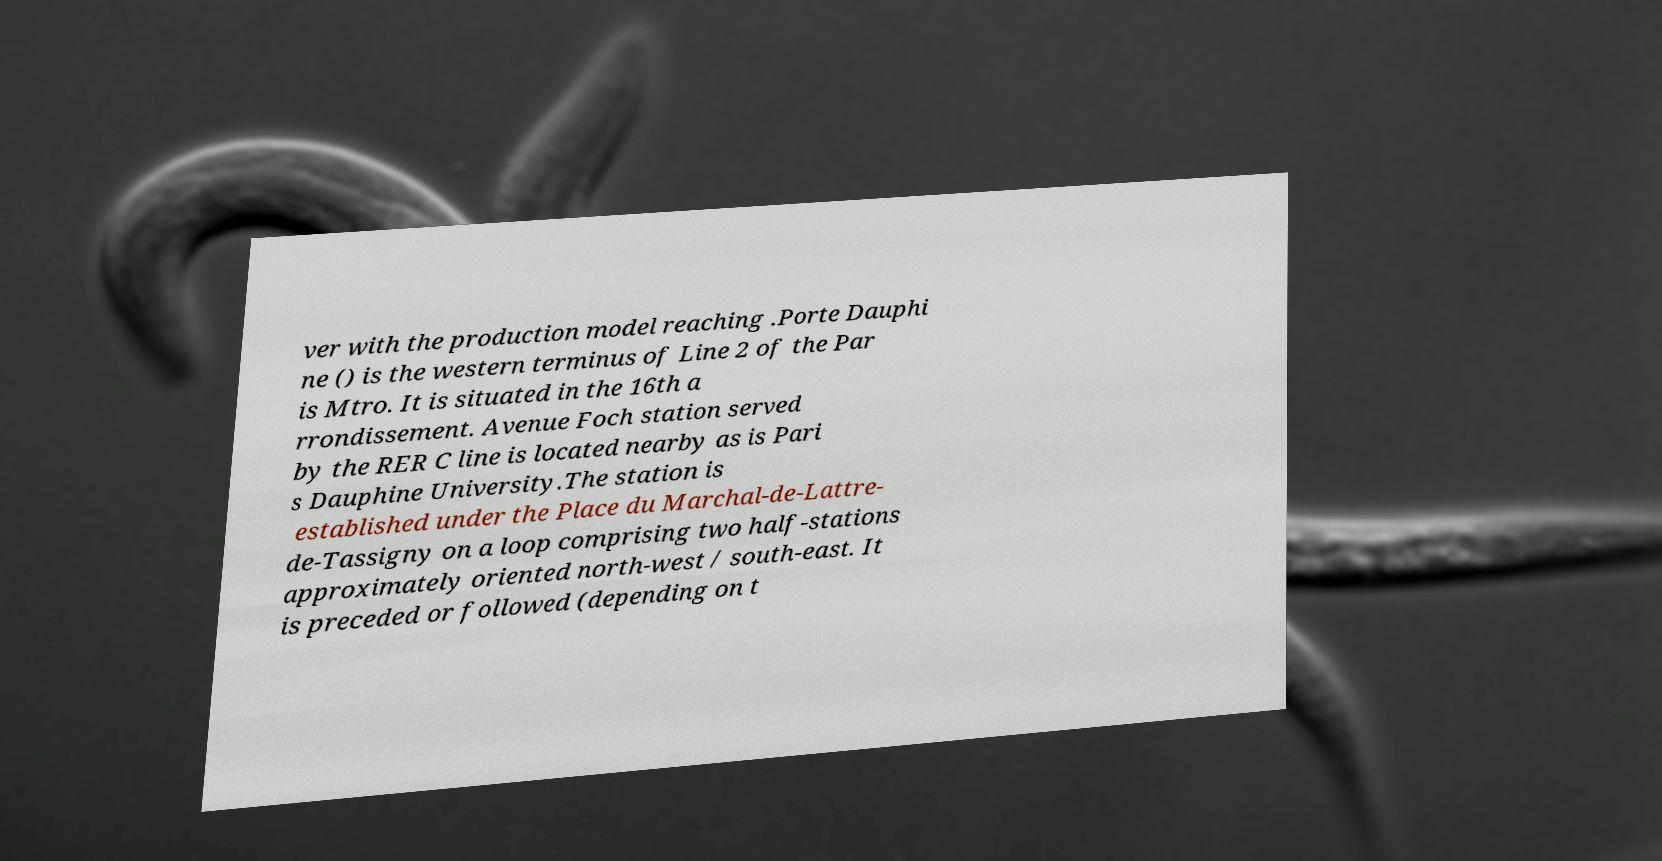What messages or text are displayed in this image? I need them in a readable, typed format. ver with the production model reaching .Porte Dauphi ne () is the western terminus of Line 2 of the Par is Mtro. It is situated in the 16th a rrondissement. Avenue Foch station served by the RER C line is located nearby as is Pari s Dauphine University.The station is established under the Place du Marchal-de-Lattre- de-Tassigny on a loop comprising two half-stations approximately oriented north-west / south-east. It is preceded or followed (depending on t 